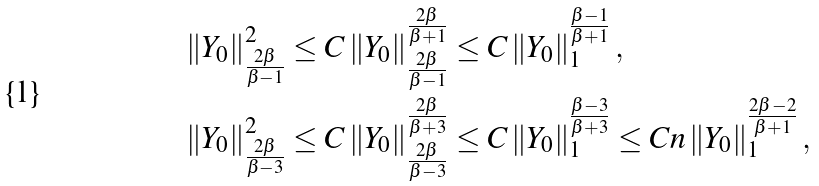Convert formula to latex. <formula><loc_0><loc_0><loc_500><loc_500>\left \| Y _ { 0 } \right \| ^ { 2 } _ { \frac { 2 \beta } { \beta - 1 } } & \leq C \left \| Y _ { 0 } \right \| ^ { \frac { 2 \beta } { \beta + 1 } } _ { \frac { 2 \beta } { \beta - 1 } } \leq C \left \| Y _ { 0 } \right \| _ { 1 } ^ { \frac { \beta - 1 } { \beta + 1 } } , \\ \left \| Y _ { 0 } \right \| _ { \frac { 2 \beta } { \beta - 3 } } ^ { 2 } & \leq C \left \| Y _ { 0 } \right \| _ { \frac { 2 \beta } { \beta - 3 } } ^ { \frac { 2 \beta } { \beta + 3 } } \leq C \left \| Y _ { 0 } \right \| _ { 1 } ^ { \frac { \beta - 3 } { \beta + 3 } } \leq C n \left \| Y _ { 0 } \right \| ^ { \frac { 2 \beta - 2 } { \beta + 1 } } _ { 1 } ,</formula> 